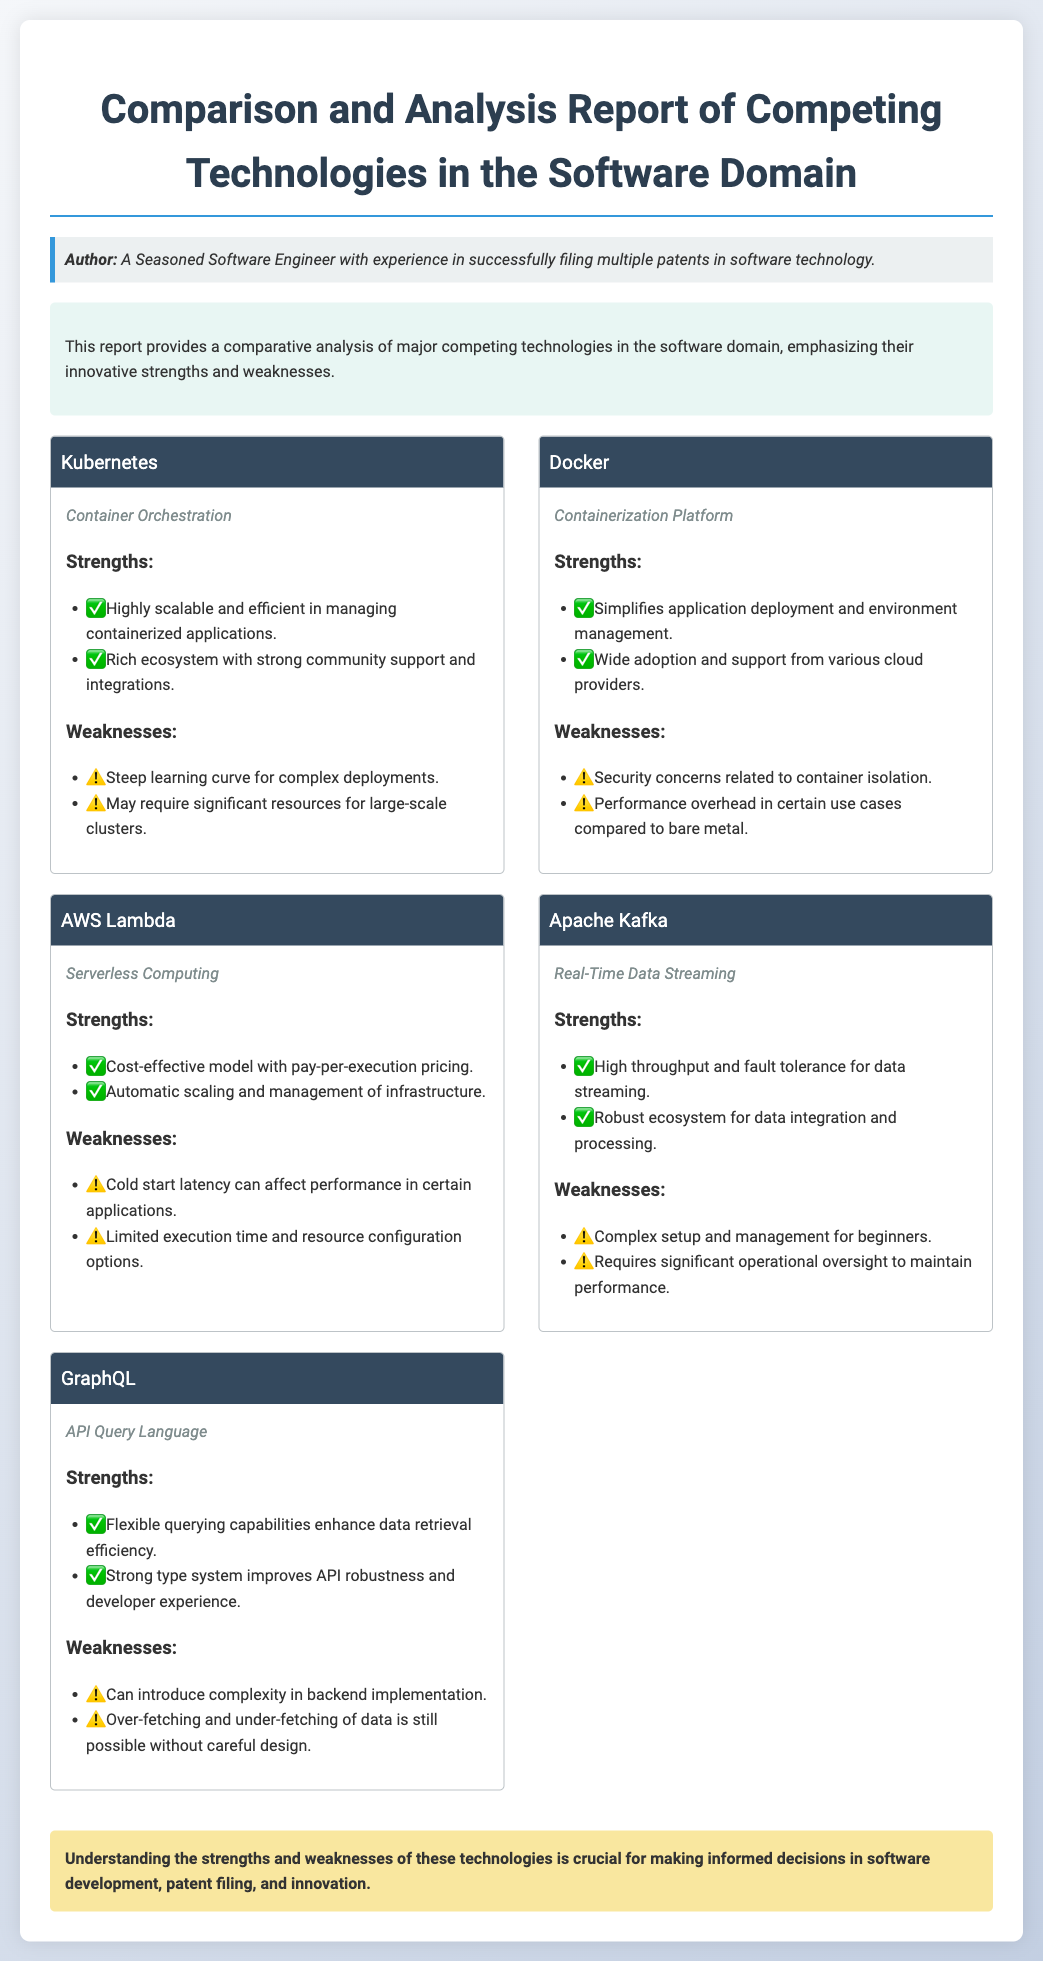What is the title of the document? The title is clearly stated at the top of the document.
Answer: Comparison and Analysis Report of Competing Technologies Who is the author of the document? The author is mentioned in the persona section.
Answer: A Seasoned Software Engineer What technology is categorized as "Container Orchestration"? The document lists technologies and their types in separate sections.
Answer: Kubernetes Which technology has a strength of "Cost-effective model with pay-per-execution pricing"? The strengths of each technology are listed under their respective sections.
Answer: AWS Lambda How many weaknesses are listed for Docker? The weaknesses of Docker are enumerated in the document.
Answer: Two What type of technology is Apache Kafka? The document specifies the type of each technology in their sections.
Answer: Real-Time Data Streaming Which technology is described as having a "Steep learning curve for complex deployments"? By reviewing the weaknesses, one can determine which technology has this issue.
Answer: Kubernetes What is a common strength mentioned for GraphQL? The strengths list includes specific capabilities of GraphQL, offering insights into its features.
Answer: Flexible querying capabilities enhance data retrieval efficiency What is the main emphasis of this report? The overview section summarizes the purpose of the document.
Answer: Innovative strengths and weaknesses 